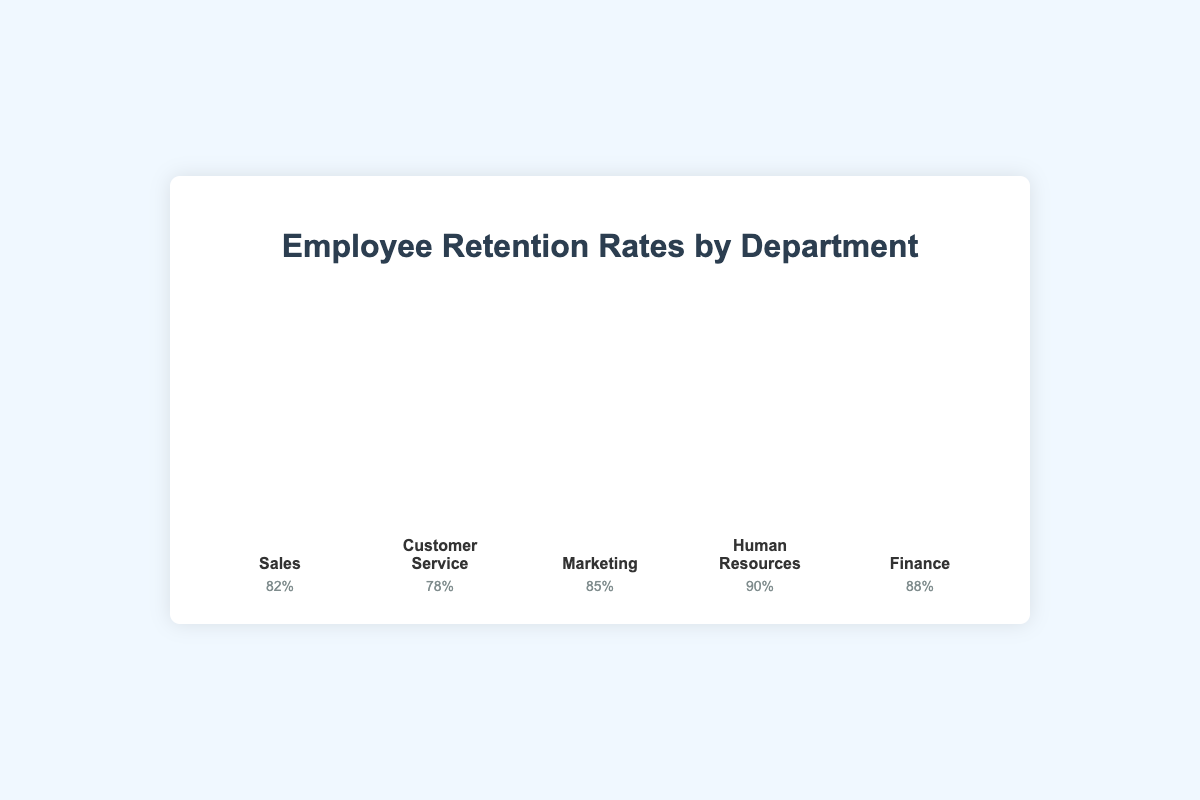What's the retention rate in the Finance department? Look for the Finance department bar. The retention rate is displayed below the icons as a percentage.
Answer: 88% Which department has the lowest retention rate? Compare all the retention rates listed under each department's bar.
Answer: Customer Service Which department's retention rate is closest to 85%? Compare each department’s retention rate with 85%.
Answer: Marketing What's the difference in retention rates between Sales and Customer Service? Subtract the retention rate of Customer Service from Sales. 82% - 78% = 4%
Answer: 4% What is the average retention rate across all departments? Add the retention rates of all departments and divide by the number of departments. (82% + 78% + 85% + 90% + 88%) / 5 = 84.6%
Answer: 84.6% Which departments have a retention rate higher than 85%? Identify and list departments with retention rates greater than 85%.
Answer: Human Resources, Finance How many departments have a retention rate lower than 80%? Count the number of departments with retention rates below 80%.
Answer: 1 What's the range of retention rates across the departments? Find the difference between the highest and lowest retention rates. 90% - 78% = 12%
Answer: 12% If the Sales department improves its retention rate by 5%, what will be the new retention rate? Add 5% to the current retention rate of Sales. 82% + 5% = 87%
Answer: 87% How does the retention rate in Customer Service compare to Finance? Compare the retention rates: 78% (Customer Service) and 88% (Finance).
Answer: Finance has a higher retention rate by 10% 